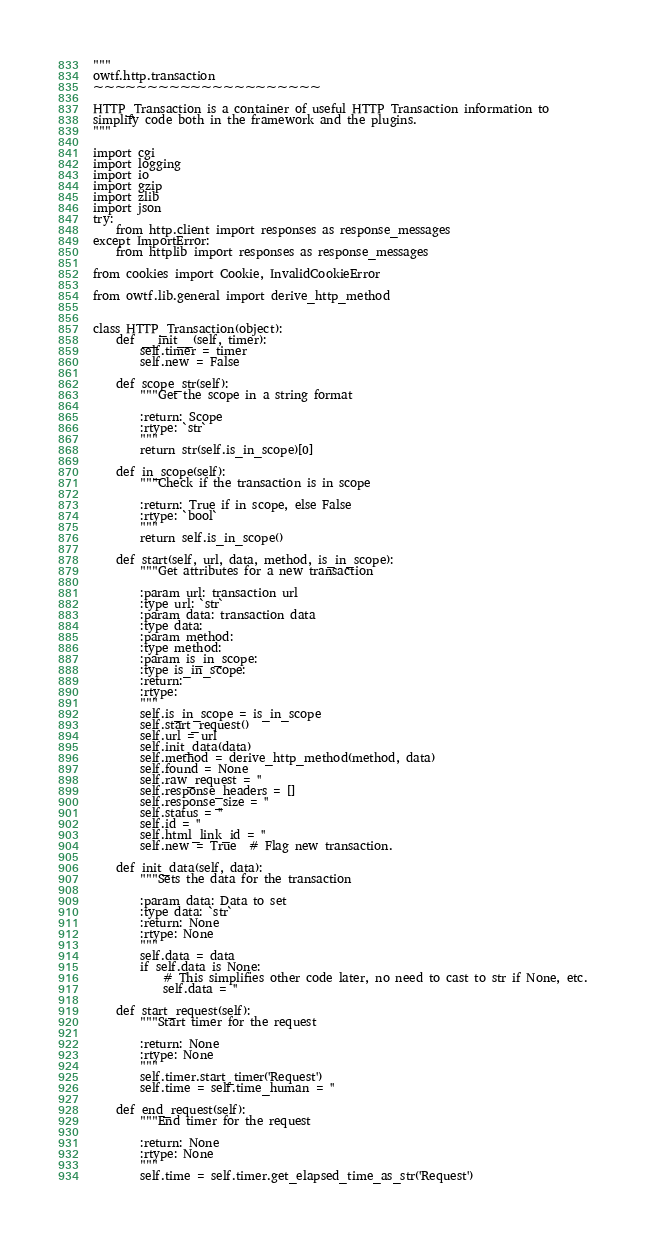<code> <loc_0><loc_0><loc_500><loc_500><_Python_>"""
owtf.http.transaction
~~~~~~~~~~~~~~~~~~~~~

HTTP_Transaction is a container of useful HTTP Transaction information to
simplify code both in the framework and the plugins.
"""

import cgi
import logging
import io
import gzip
import zlib
import json
try:
    from http.client import responses as response_messages
except ImportError:
    from httplib import responses as response_messages

from cookies import Cookie, InvalidCookieError

from owtf.lib.general import derive_http_method


class HTTP_Transaction(object):
    def __init__(self, timer):
        self.timer = timer
        self.new = False

    def scope_str(self):
        """Get the scope in a string format

        :return: Scope
        :rtype: `str`
        """
        return str(self.is_in_scope)[0]

    def in_scope(self):
        """Check if the transaction is in scope

        :return: True if in scope, else False
        :rtype: `bool`
        """
        return self.is_in_scope()

    def start(self, url, data, method, is_in_scope):
        """Get attributes for a new transaction

        :param url: transaction url
        :type url: `str`
        :param data: transaction data
        :type data:
        :param method:
        :type method:
        :param is_in_scope:
        :type is_in_scope:
        :return:
        :rtype:
        """
        self.is_in_scope = is_in_scope
        self.start_request()
        self.url = url
        self.init_data(data)
        self.method = derive_http_method(method, data)
        self.found = None
        self.raw_request = ''
        self.response_headers = []
        self.response_size = ''
        self.status = ''
        self.id = ''
        self.html_link_id = ''
        self.new = True  # Flag new transaction.

    def init_data(self, data):
        """Sets the data for the transaction

        :param data: Data to set
        :type data: `str`
        :return: None
        :rtype: None
        """
        self.data = data
        if self.data is None:
            # This simplifies other code later, no need to cast to str if None, etc.
            self.data = ''

    def start_request(self):
        """Start timer for the request

        :return: None
        :rtype: None
        """
        self.timer.start_timer('Request')
        self.time = self.time_human = ''

    def end_request(self):
        """End timer for the request

        :return: None
        :rtype: None
        """
        self.time = self.timer.get_elapsed_time_as_str('Request')</code> 